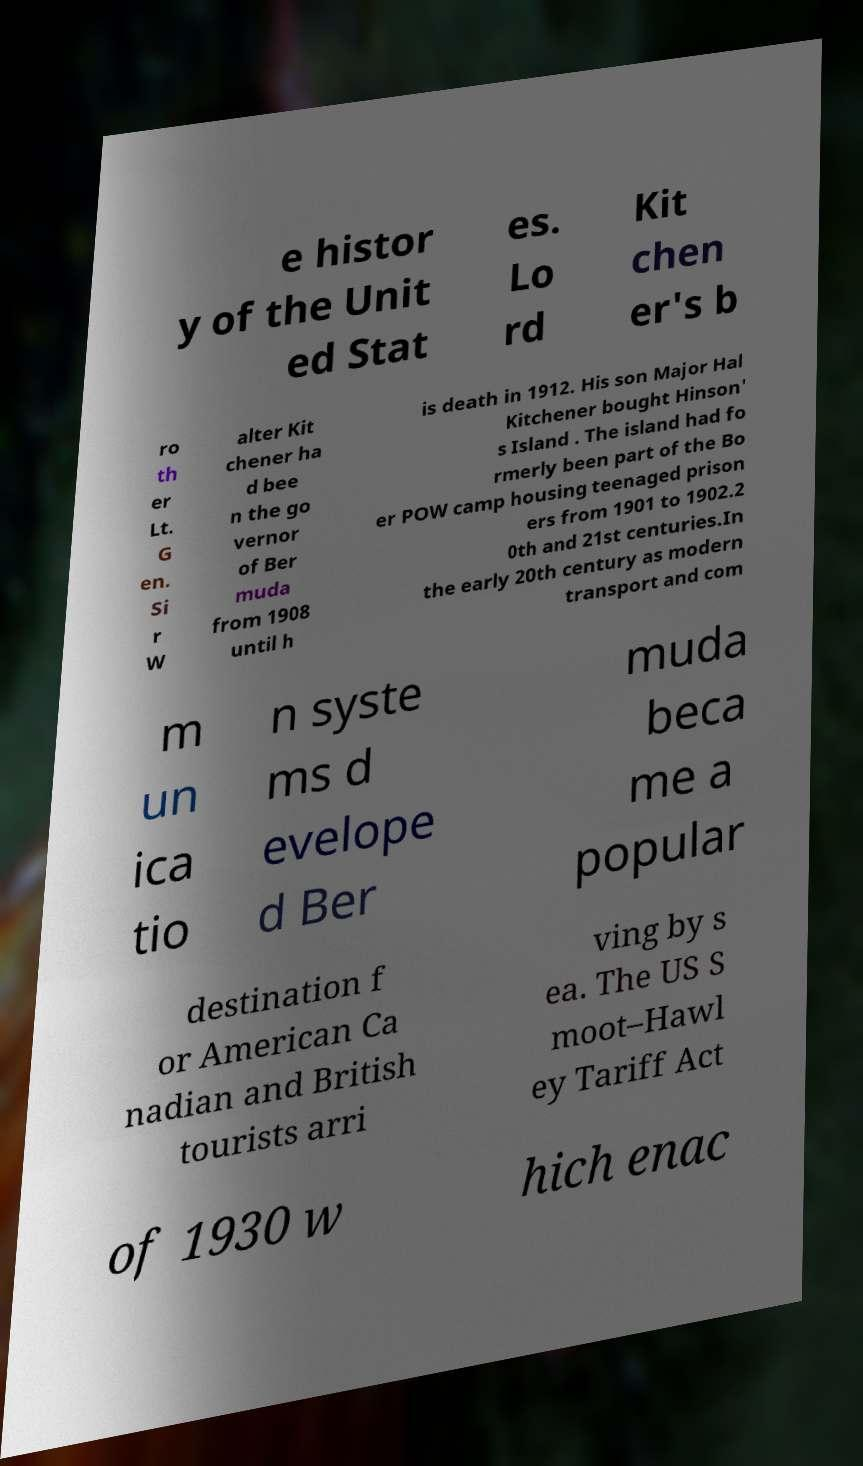Could you extract and type out the text from this image? e histor y of the Unit ed Stat es. Lo rd Kit chen er's b ro th er Lt. G en. Si r W alter Kit chener ha d bee n the go vernor of Ber muda from 1908 until h is death in 1912. His son Major Hal Kitchener bought Hinson' s Island . The island had fo rmerly been part of the Bo er POW camp housing teenaged prison ers from 1901 to 1902.2 0th and 21st centuries.In the early 20th century as modern transport and com m un ica tio n syste ms d evelope d Ber muda beca me a popular destination f or American Ca nadian and British tourists arri ving by s ea. The US S moot–Hawl ey Tariff Act of 1930 w hich enac 